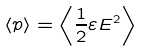Convert formula to latex. <formula><loc_0><loc_0><loc_500><loc_500>\left < p \right > = \left < \frac { 1 } { 2 } \varepsilon E ^ { 2 } \right ></formula> 